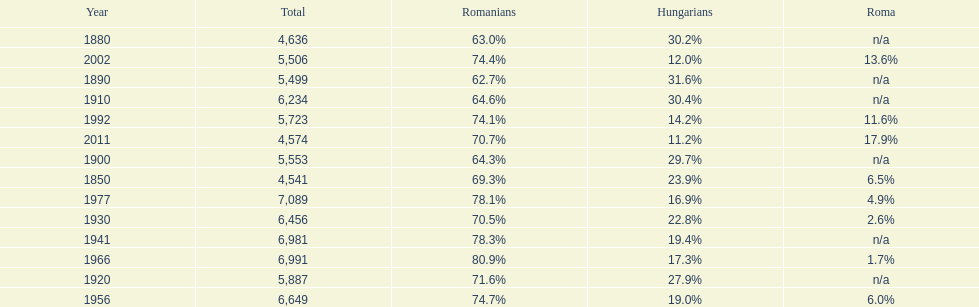In which year was the highest proportion of hungarians observed? 1890. 